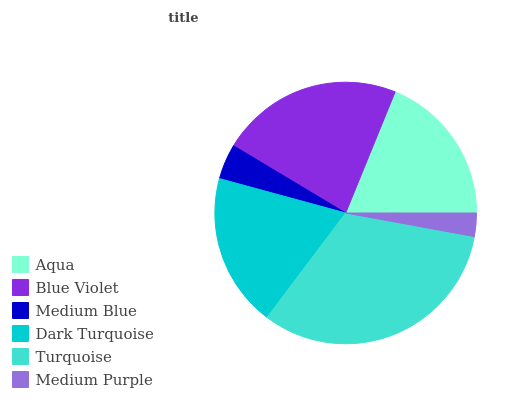Is Medium Purple the minimum?
Answer yes or no. Yes. Is Turquoise the maximum?
Answer yes or no. Yes. Is Blue Violet the minimum?
Answer yes or no. No. Is Blue Violet the maximum?
Answer yes or no. No. Is Blue Violet greater than Aqua?
Answer yes or no. Yes. Is Aqua less than Blue Violet?
Answer yes or no. Yes. Is Aqua greater than Blue Violet?
Answer yes or no. No. Is Blue Violet less than Aqua?
Answer yes or no. No. Is Dark Turquoise the high median?
Answer yes or no. Yes. Is Aqua the low median?
Answer yes or no. Yes. Is Blue Violet the high median?
Answer yes or no. No. Is Medium Purple the low median?
Answer yes or no. No. 